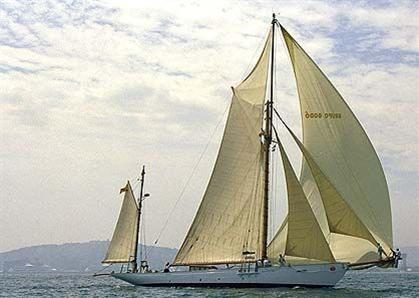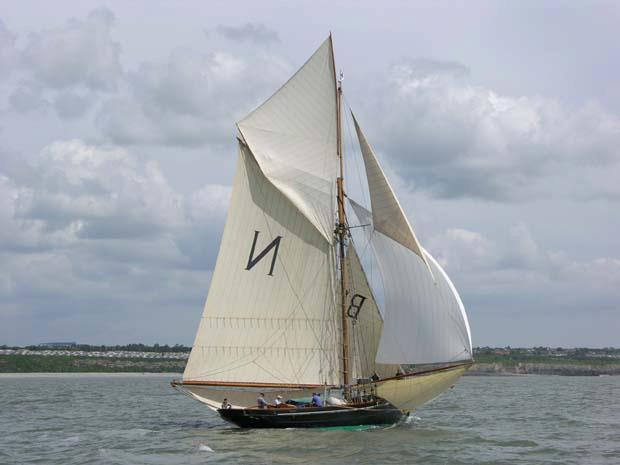The first image is the image on the left, the second image is the image on the right. Examine the images to the left and right. Is the description "In the image to the left, the boat has more than four sails unfurled." accurate? Answer yes or no. Yes. 